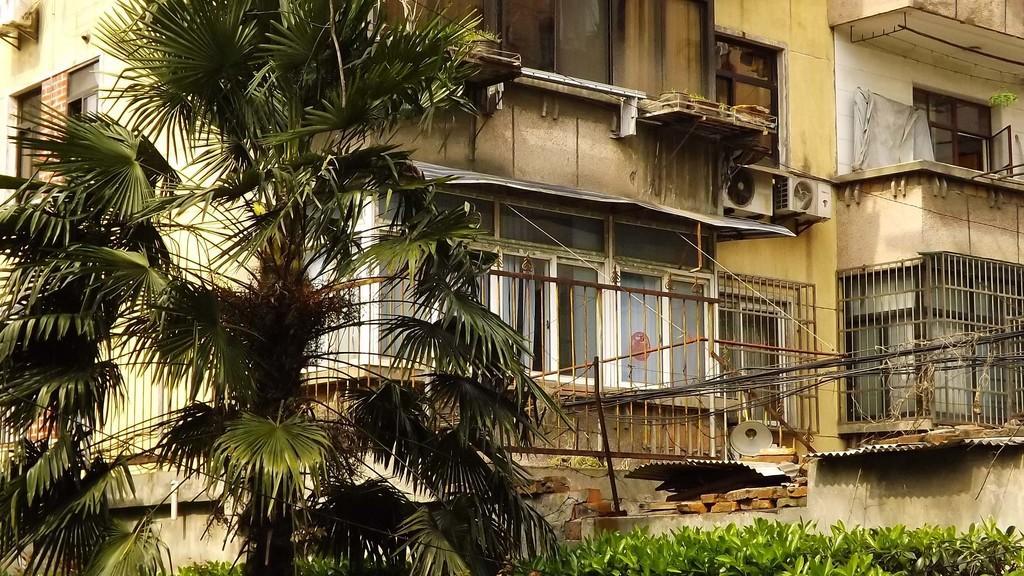Can you describe this image briefly? In this picture we can see a building, grilles, railing, windows, plants, objects, metal panels, bricks and a tree. At the bottom portion of the picture we can see the leaves. 